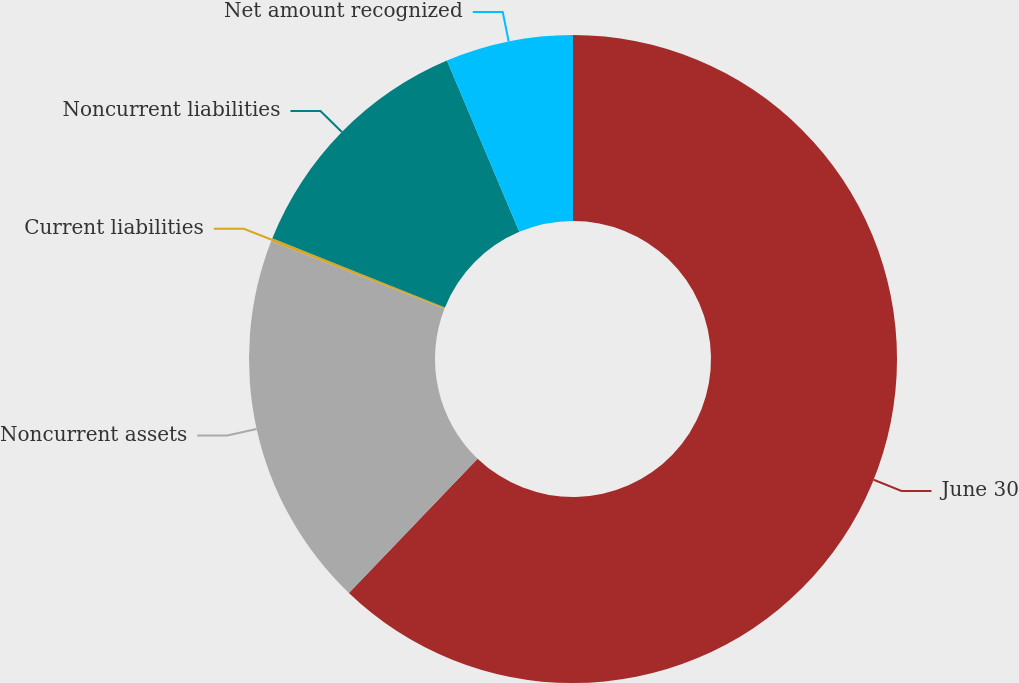Convert chart. <chart><loc_0><loc_0><loc_500><loc_500><pie_chart><fcel>June 30<fcel>Noncurrent assets<fcel>Current liabilities<fcel>Noncurrent liabilities<fcel>Net amount recognized<nl><fcel>62.15%<fcel>18.76%<fcel>0.16%<fcel>12.56%<fcel>6.36%<nl></chart> 